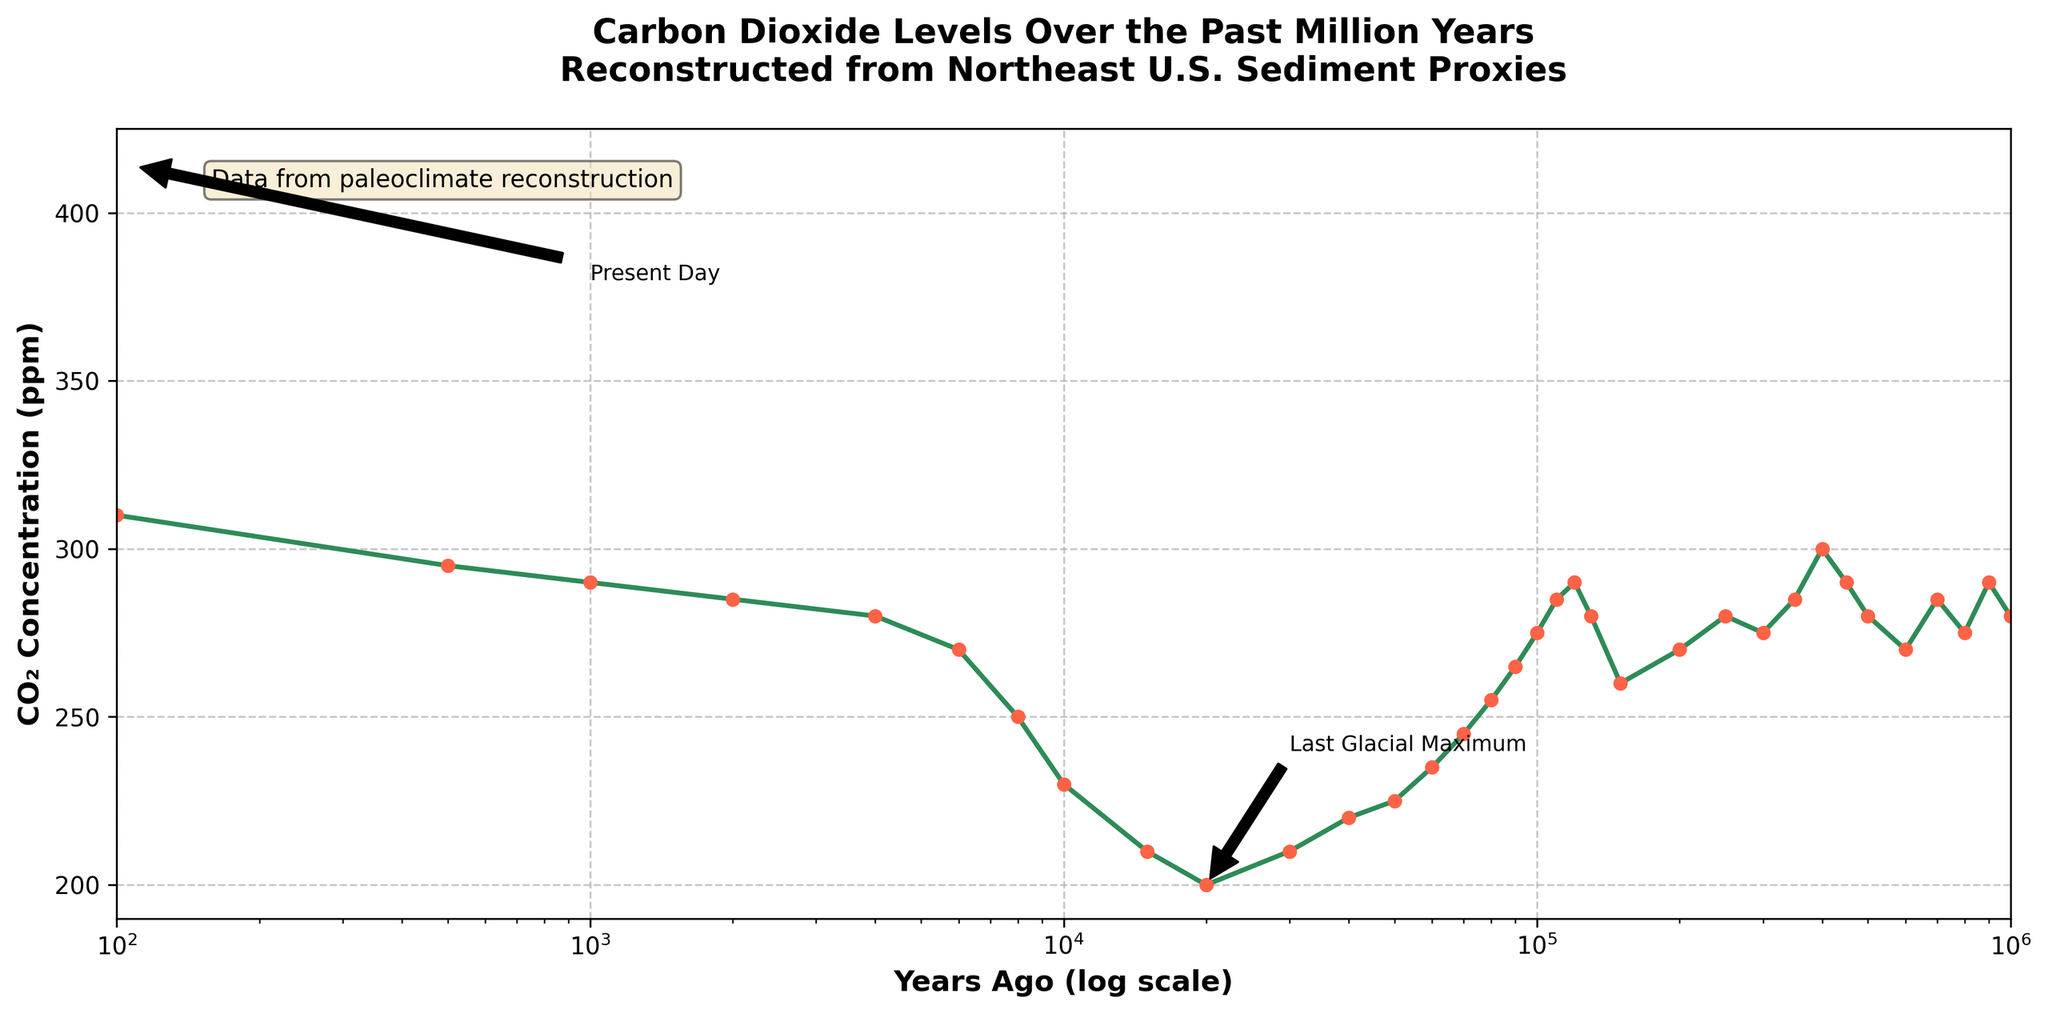What is the CO₂ concentration 500,000 years ago? Looking at the point corresponding to 500,000 years ago on the x-axis, we see that the CO₂ concentration is marked by a green line intersecting at 280 ppm.
Answer: 280 ppm How much did the CO₂ concentration increase from 1,000 years ago to present day? At 1,000 years ago, the CO₂ concentration was 290 ppm, and at present day (0 years ago), it is 415 ppm. The increase is calculated by subtracting the earlier value from the later value: 415 ppm - 290 ppm = 125 ppm.
Answer: 125 ppm During which period did the CO₂ concentration decrease the most rapidly? Observing the steepest declines in the plotted data, we notice that the sharpest decrease occurs between 120,000 and 70,000 years ago, where CO₂ concentration drops from around 290 ppm to 245 ppm.
Answer: 120,000 to 70,000 years ago What is the average CO₂ concentration between 450,000 and 350,000 years ago? The CO₂ concentrations at the specified points are 290 ppm at 450,000 years, 300 ppm at 400,000 years, and 285 ppm at 350,000 years. The average is calculated by summing these values (290 + 300 + 285) and dividing by 3: (290 + 300 + 285) / 3 = 291.67 ppm.
Answer: 291.67 ppm How does the CO₂ concentration 200,000 years ago compare with that 100,000 years ago? At 200,000 years ago, the CO₂ concentration was 270 ppm, while at 100,000 years ago, it was 275 ppm. Thus, the concentration increased by 5 ppm over this period.
Answer: Increased by 5 ppm What are the CO₂ concentration levels during the Last Glacial Maximum? The annotation on the plot indicates the Last Glacial Maximum around 20,000 years ago, where the CO₂ concentration is marked at approximately 200 ppm.
Answer: 200 ppm How does the CO₂ concentration 800,000 years ago compare to 600,000 years ago? The CO₂ concentration 800,000 years ago was 275 ppm, while at 600,000 years ago it was 270 ppm. Therefore, it decreased by 5 ppm across this time span.
Answer: Decreased by 5 ppm Which period shows a higher CO₂ concentration, the Holocene or the last 100 years? Observing the plot, CO₂ concentrations during the Holocene (starting roughly 10,000 years ago) rise to around 230-295 ppm. In the last 100 years, the concentration escalates to 415 ppm. Hence, the last 100 years show a higher concentration.
Answer: Last 100 years How did CO₂ levels change from the Last Glacial Maximum to present day? From 20,000 years ago (Last Glacial Maximum with CO₂ at 200 ppm) till today (415 ppm), the CO₂ levels increased significantly by 215 ppm.
Answer: Increased by 215 ppm What is the CO₂ concentration at the end of the Pleistocene epoch, around 10,000 years ago? Checking the data point for 10,000 years ago, the CO₂ concentration is marked at approximately 230 ppm.
Answer: 230 ppm 